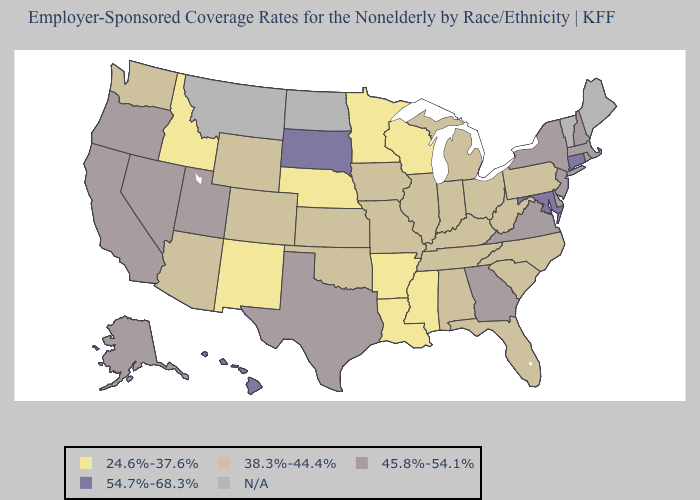What is the value of Washington?
Quick response, please. 38.3%-44.4%. Among the states that border Montana , does Wyoming have the highest value?
Concise answer only. No. What is the value of Massachusetts?
Answer briefly. 45.8%-54.1%. Which states have the highest value in the USA?
Quick response, please. Connecticut, Hawaii, Maryland, South Dakota. Which states hav the highest value in the Northeast?
Short answer required. Connecticut. Does Oklahoma have the lowest value in the USA?
Be succinct. No. Does South Dakota have the highest value in the USA?
Write a very short answer. Yes. Which states have the highest value in the USA?
Be succinct. Connecticut, Hawaii, Maryland, South Dakota. Which states hav the highest value in the Northeast?
Concise answer only. Connecticut. Among the states that border Montana , does South Dakota have the highest value?
Give a very brief answer. Yes. Name the states that have a value in the range N/A?
Keep it brief. Maine, Montana, North Dakota, Vermont. Does the first symbol in the legend represent the smallest category?
Concise answer only. Yes. How many symbols are there in the legend?
Short answer required. 5. 